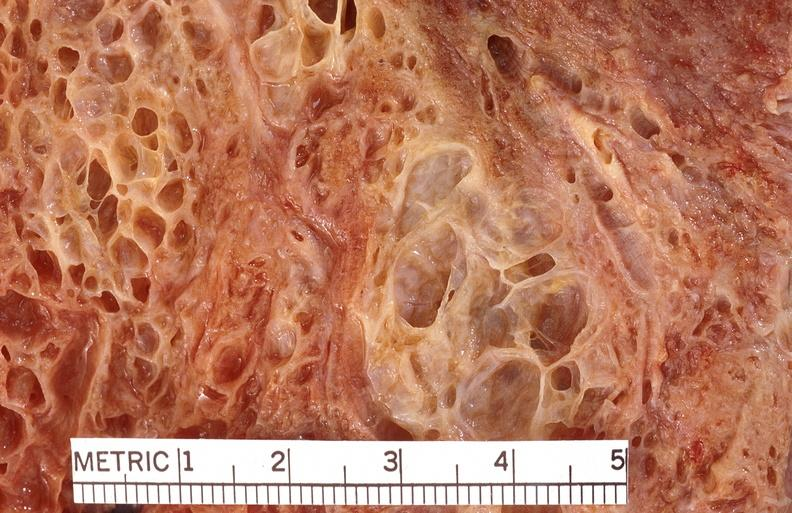does this image show lung fibrosis, scleroderma?
Answer the question using a single word or phrase. Yes 